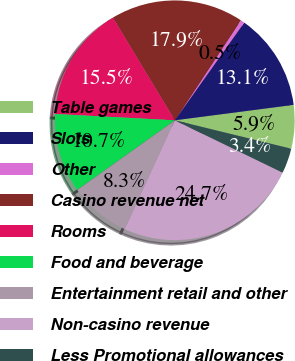Convert chart. <chart><loc_0><loc_0><loc_500><loc_500><pie_chart><fcel>Table games<fcel>Slots<fcel>Other<fcel>Casino revenue net<fcel>Rooms<fcel>Food and beverage<fcel>Entertainment retail and other<fcel>Non-casino revenue<fcel>Less Promotional allowances<nl><fcel>5.87%<fcel>13.11%<fcel>0.54%<fcel>17.93%<fcel>15.52%<fcel>10.7%<fcel>8.28%<fcel>24.66%<fcel>3.38%<nl></chart> 